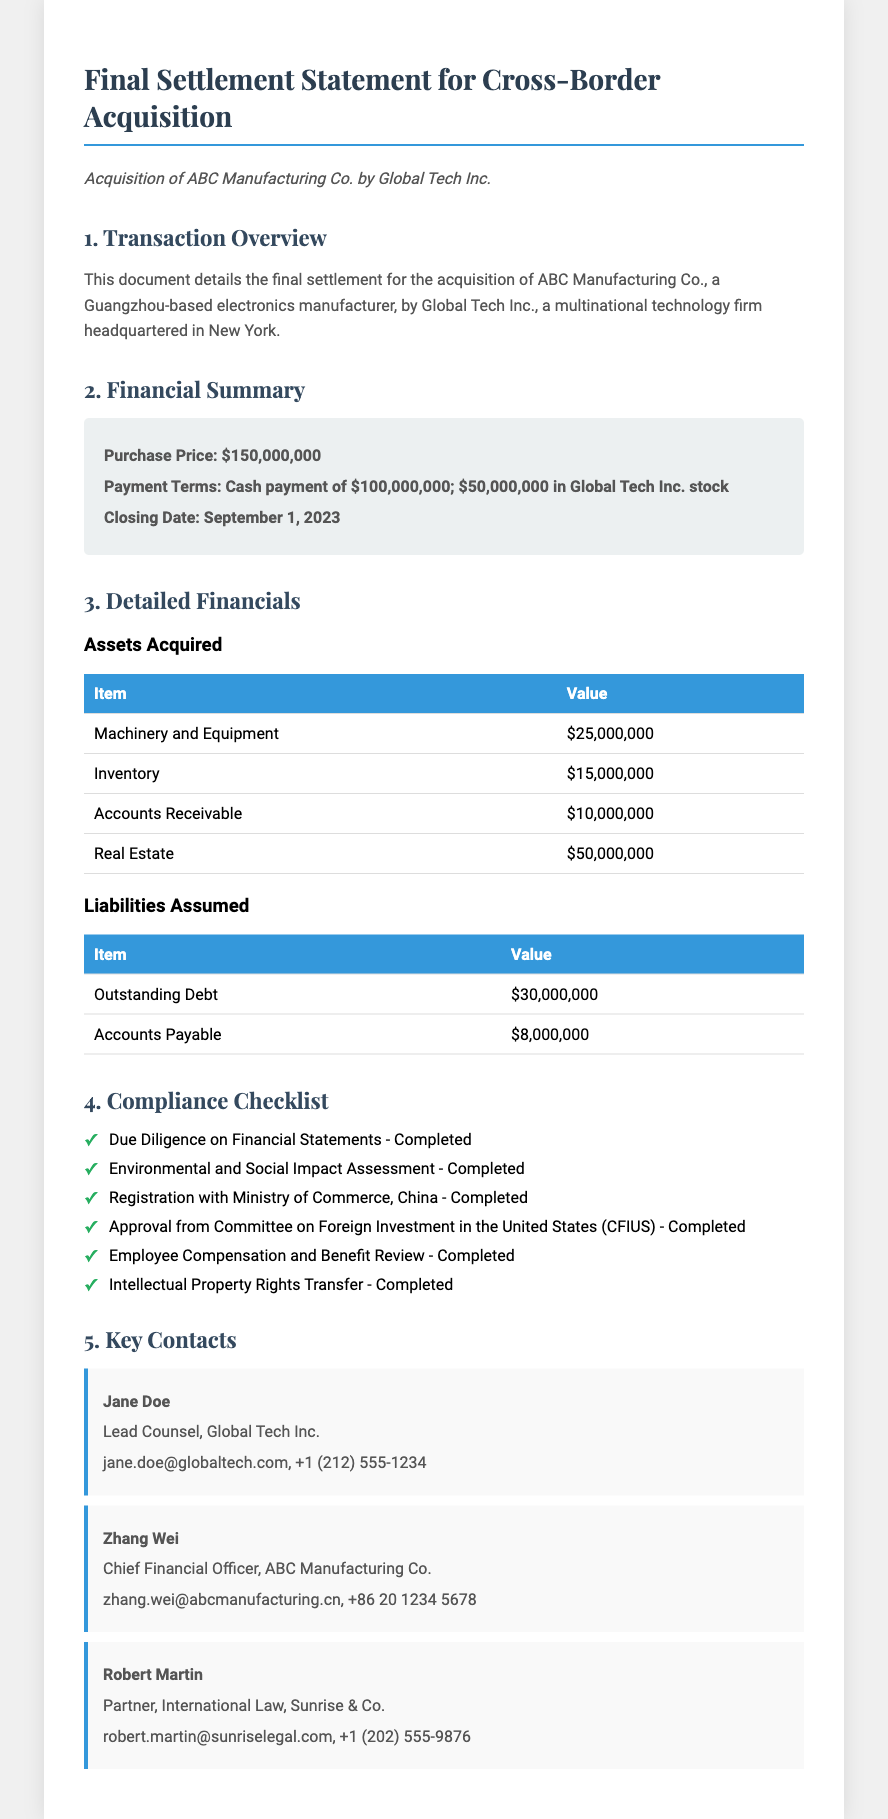What is the purchase price? The purchase price is clearly stated in the Financial Summary section of the document as $150,000,000.
Answer: $150,000,000 What is the closing date of the acquisition? The closing date is mentioned in the Financial Summary section as September 1, 2023.
Answer: September 1, 2023 What assets were acquired? The assets acquired include Machinery and Equipment, Inventory, Accounts Receivable, and Real Estate as detailed in the Detailed Financials section.
Answer: Machinery and Equipment, Inventory, Accounts Receivable, Real Estate What is the value of outstanding debt? The value of outstanding debt is specified in the Liabilities Assumed table as $30,000,000.
Answer: $30,000,000 How many compliance checks have been completed? The Compliance Checklist outlines six items, all of which are marked as completed.
Answer: Six Who is the Lead Counsel for Global Tech Inc.? The document lists Jane Doe as the Lead Counsel for Global Tech Inc. in the Key Contacts section.
Answer: Jane Doe What agency approved the acquisition from the US side? The agency that approved the acquisition is stated in the Compliance Checklist as the Committee on Foreign Investment in the United States (CFIUS).
Answer: Committee on Foreign Investment in the United States (CFIUS) What is the total value of accounts receivable? The value is clearly listed in the Detailed Financials section under Assets Acquired as $10,000,000.
Answer: $10,000,000 What was the payment term for Global Tech Inc.? The payment terms specify a cash payment of $100,000,000 and $50,000,000 in Global Tech Inc. stock as indicated in the Financial Summary.
Answer: Cash payment of $100,000,000; $50,000,000 in Global Tech Inc. stock 